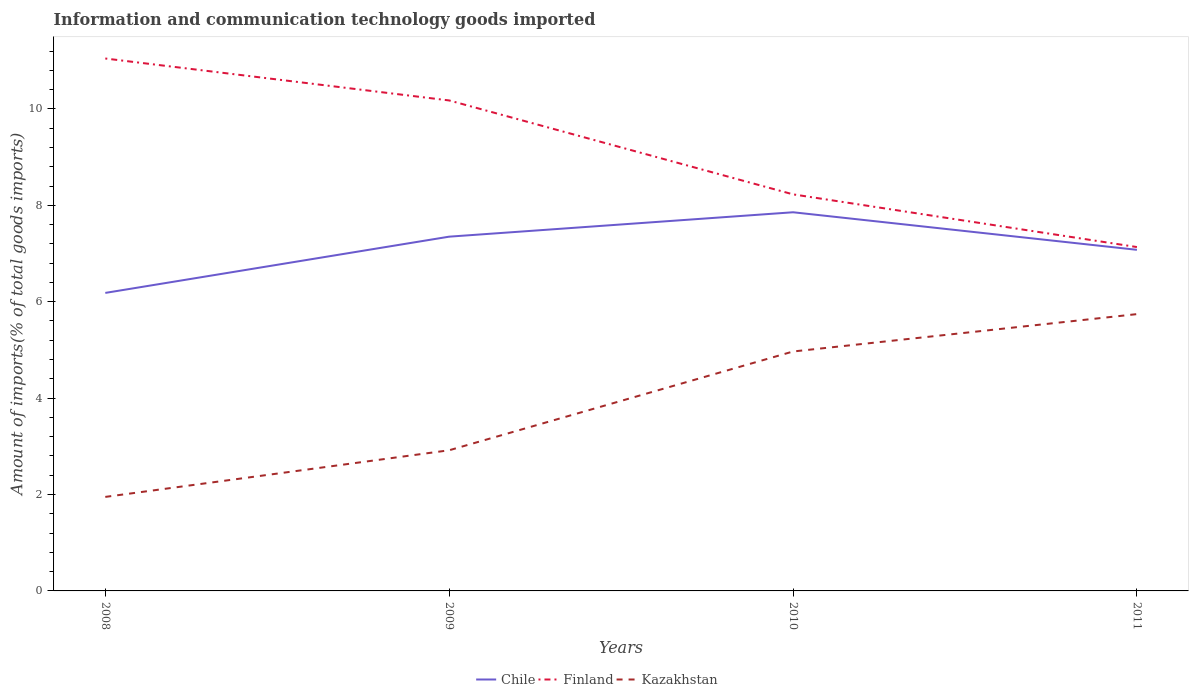How many different coloured lines are there?
Offer a very short reply. 3. Does the line corresponding to Kazakhstan intersect with the line corresponding to Chile?
Offer a terse response. No. Is the number of lines equal to the number of legend labels?
Provide a short and direct response. Yes. Across all years, what is the maximum amount of goods imported in Finland?
Make the answer very short. 7.13. In which year was the amount of goods imported in Chile maximum?
Provide a short and direct response. 2008. What is the total amount of goods imported in Kazakhstan in the graph?
Your answer should be compact. -2.05. What is the difference between the highest and the second highest amount of goods imported in Chile?
Your answer should be compact. 1.67. Is the amount of goods imported in Finland strictly greater than the amount of goods imported in Chile over the years?
Offer a very short reply. No. How many lines are there?
Offer a terse response. 3. What is the difference between two consecutive major ticks on the Y-axis?
Make the answer very short. 2. Does the graph contain any zero values?
Provide a succinct answer. No. What is the title of the graph?
Provide a short and direct response. Information and communication technology goods imported. What is the label or title of the X-axis?
Give a very brief answer. Years. What is the label or title of the Y-axis?
Offer a very short reply. Amount of imports(% of total goods imports). What is the Amount of imports(% of total goods imports) of Chile in 2008?
Ensure brevity in your answer.  6.18. What is the Amount of imports(% of total goods imports) of Finland in 2008?
Provide a short and direct response. 11.05. What is the Amount of imports(% of total goods imports) of Kazakhstan in 2008?
Your response must be concise. 1.95. What is the Amount of imports(% of total goods imports) of Chile in 2009?
Offer a very short reply. 7.35. What is the Amount of imports(% of total goods imports) in Finland in 2009?
Keep it short and to the point. 10.18. What is the Amount of imports(% of total goods imports) of Kazakhstan in 2009?
Your response must be concise. 2.92. What is the Amount of imports(% of total goods imports) in Chile in 2010?
Provide a short and direct response. 7.86. What is the Amount of imports(% of total goods imports) in Finland in 2010?
Your answer should be very brief. 8.23. What is the Amount of imports(% of total goods imports) of Kazakhstan in 2010?
Offer a very short reply. 4.97. What is the Amount of imports(% of total goods imports) in Chile in 2011?
Your answer should be compact. 7.08. What is the Amount of imports(% of total goods imports) in Finland in 2011?
Give a very brief answer. 7.13. What is the Amount of imports(% of total goods imports) in Kazakhstan in 2011?
Provide a short and direct response. 5.74. Across all years, what is the maximum Amount of imports(% of total goods imports) in Chile?
Ensure brevity in your answer.  7.86. Across all years, what is the maximum Amount of imports(% of total goods imports) in Finland?
Your answer should be very brief. 11.05. Across all years, what is the maximum Amount of imports(% of total goods imports) in Kazakhstan?
Your answer should be compact. 5.74. Across all years, what is the minimum Amount of imports(% of total goods imports) of Chile?
Ensure brevity in your answer.  6.18. Across all years, what is the minimum Amount of imports(% of total goods imports) in Finland?
Provide a succinct answer. 7.13. Across all years, what is the minimum Amount of imports(% of total goods imports) in Kazakhstan?
Provide a succinct answer. 1.95. What is the total Amount of imports(% of total goods imports) in Chile in the graph?
Your answer should be compact. 28.46. What is the total Amount of imports(% of total goods imports) of Finland in the graph?
Offer a terse response. 36.58. What is the total Amount of imports(% of total goods imports) in Kazakhstan in the graph?
Offer a terse response. 15.58. What is the difference between the Amount of imports(% of total goods imports) in Chile in 2008 and that in 2009?
Your answer should be compact. -1.17. What is the difference between the Amount of imports(% of total goods imports) in Finland in 2008 and that in 2009?
Offer a terse response. 0.87. What is the difference between the Amount of imports(% of total goods imports) in Kazakhstan in 2008 and that in 2009?
Your response must be concise. -0.97. What is the difference between the Amount of imports(% of total goods imports) in Chile in 2008 and that in 2010?
Give a very brief answer. -1.67. What is the difference between the Amount of imports(% of total goods imports) of Finland in 2008 and that in 2010?
Your answer should be very brief. 2.82. What is the difference between the Amount of imports(% of total goods imports) of Kazakhstan in 2008 and that in 2010?
Ensure brevity in your answer.  -3.02. What is the difference between the Amount of imports(% of total goods imports) in Chile in 2008 and that in 2011?
Keep it short and to the point. -0.89. What is the difference between the Amount of imports(% of total goods imports) of Finland in 2008 and that in 2011?
Your answer should be very brief. 3.91. What is the difference between the Amount of imports(% of total goods imports) of Kazakhstan in 2008 and that in 2011?
Ensure brevity in your answer.  -3.79. What is the difference between the Amount of imports(% of total goods imports) in Chile in 2009 and that in 2010?
Ensure brevity in your answer.  -0.51. What is the difference between the Amount of imports(% of total goods imports) in Finland in 2009 and that in 2010?
Provide a succinct answer. 1.95. What is the difference between the Amount of imports(% of total goods imports) of Kazakhstan in 2009 and that in 2010?
Make the answer very short. -2.05. What is the difference between the Amount of imports(% of total goods imports) of Chile in 2009 and that in 2011?
Ensure brevity in your answer.  0.27. What is the difference between the Amount of imports(% of total goods imports) of Finland in 2009 and that in 2011?
Provide a short and direct response. 3.04. What is the difference between the Amount of imports(% of total goods imports) in Kazakhstan in 2009 and that in 2011?
Your response must be concise. -2.82. What is the difference between the Amount of imports(% of total goods imports) of Chile in 2010 and that in 2011?
Keep it short and to the point. 0.78. What is the difference between the Amount of imports(% of total goods imports) of Finland in 2010 and that in 2011?
Offer a very short reply. 1.09. What is the difference between the Amount of imports(% of total goods imports) in Kazakhstan in 2010 and that in 2011?
Provide a succinct answer. -0.78. What is the difference between the Amount of imports(% of total goods imports) of Chile in 2008 and the Amount of imports(% of total goods imports) of Finland in 2009?
Your response must be concise. -3.99. What is the difference between the Amount of imports(% of total goods imports) of Chile in 2008 and the Amount of imports(% of total goods imports) of Kazakhstan in 2009?
Give a very brief answer. 3.26. What is the difference between the Amount of imports(% of total goods imports) in Finland in 2008 and the Amount of imports(% of total goods imports) in Kazakhstan in 2009?
Offer a terse response. 8.13. What is the difference between the Amount of imports(% of total goods imports) of Chile in 2008 and the Amount of imports(% of total goods imports) of Finland in 2010?
Give a very brief answer. -2.04. What is the difference between the Amount of imports(% of total goods imports) of Chile in 2008 and the Amount of imports(% of total goods imports) of Kazakhstan in 2010?
Your answer should be very brief. 1.22. What is the difference between the Amount of imports(% of total goods imports) in Finland in 2008 and the Amount of imports(% of total goods imports) in Kazakhstan in 2010?
Your answer should be very brief. 6.08. What is the difference between the Amount of imports(% of total goods imports) in Chile in 2008 and the Amount of imports(% of total goods imports) in Finland in 2011?
Your response must be concise. -0.95. What is the difference between the Amount of imports(% of total goods imports) of Chile in 2008 and the Amount of imports(% of total goods imports) of Kazakhstan in 2011?
Offer a terse response. 0.44. What is the difference between the Amount of imports(% of total goods imports) of Finland in 2008 and the Amount of imports(% of total goods imports) of Kazakhstan in 2011?
Provide a succinct answer. 5.3. What is the difference between the Amount of imports(% of total goods imports) in Chile in 2009 and the Amount of imports(% of total goods imports) in Finland in 2010?
Provide a succinct answer. -0.88. What is the difference between the Amount of imports(% of total goods imports) of Chile in 2009 and the Amount of imports(% of total goods imports) of Kazakhstan in 2010?
Keep it short and to the point. 2.38. What is the difference between the Amount of imports(% of total goods imports) in Finland in 2009 and the Amount of imports(% of total goods imports) in Kazakhstan in 2010?
Your response must be concise. 5.21. What is the difference between the Amount of imports(% of total goods imports) of Chile in 2009 and the Amount of imports(% of total goods imports) of Finland in 2011?
Give a very brief answer. 0.22. What is the difference between the Amount of imports(% of total goods imports) in Chile in 2009 and the Amount of imports(% of total goods imports) in Kazakhstan in 2011?
Offer a very short reply. 1.61. What is the difference between the Amount of imports(% of total goods imports) of Finland in 2009 and the Amount of imports(% of total goods imports) of Kazakhstan in 2011?
Make the answer very short. 4.43. What is the difference between the Amount of imports(% of total goods imports) of Chile in 2010 and the Amount of imports(% of total goods imports) of Finland in 2011?
Offer a terse response. 0.72. What is the difference between the Amount of imports(% of total goods imports) in Chile in 2010 and the Amount of imports(% of total goods imports) in Kazakhstan in 2011?
Make the answer very short. 2.11. What is the difference between the Amount of imports(% of total goods imports) in Finland in 2010 and the Amount of imports(% of total goods imports) in Kazakhstan in 2011?
Make the answer very short. 2.48. What is the average Amount of imports(% of total goods imports) in Chile per year?
Make the answer very short. 7.12. What is the average Amount of imports(% of total goods imports) of Finland per year?
Your answer should be compact. 9.15. What is the average Amount of imports(% of total goods imports) in Kazakhstan per year?
Provide a succinct answer. 3.89. In the year 2008, what is the difference between the Amount of imports(% of total goods imports) in Chile and Amount of imports(% of total goods imports) in Finland?
Give a very brief answer. -4.86. In the year 2008, what is the difference between the Amount of imports(% of total goods imports) in Chile and Amount of imports(% of total goods imports) in Kazakhstan?
Keep it short and to the point. 4.23. In the year 2008, what is the difference between the Amount of imports(% of total goods imports) in Finland and Amount of imports(% of total goods imports) in Kazakhstan?
Your response must be concise. 9.1. In the year 2009, what is the difference between the Amount of imports(% of total goods imports) in Chile and Amount of imports(% of total goods imports) in Finland?
Provide a succinct answer. -2.83. In the year 2009, what is the difference between the Amount of imports(% of total goods imports) of Chile and Amount of imports(% of total goods imports) of Kazakhstan?
Make the answer very short. 4.43. In the year 2009, what is the difference between the Amount of imports(% of total goods imports) of Finland and Amount of imports(% of total goods imports) of Kazakhstan?
Offer a very short reply. 7.26. In the year 2010, what is the difference between the Amount of imports(% of total goods imports) of Chile and Amount of imports(% of total goods imports) of Finland?
Keep it short and to the point. -0.37. In the year 2010, what is the difference between the Amount of imports(% of total goods imports) in Chile and Amount of imports(% of total goods imports) in Kazakhstan?
Offer a very short reply. 2.89. In the year 2010, what is the difference between the Amount of imports(% of total goods imports) in Finland and Amount of imports(% of total goods imports) in Kazakhstan?
Provide a succinct answer. 3.26. In the year 2011, what is the difference between the Amount of imports(% of total goods imports) of Chile and Amount of imports(% of total goods imports) of Finland?
Give a very brief answer. -0.06. In the year 2011, what is the difference between the Amount of imports(% of total goods imports) of Chile and Amount of imports(% of total goods imports) of Kazakhstan?
Your response must be concise. 1.33. In the year 2011, what is the difference between the Amount of imports(% of total goods imports) of Finland and Amount of imports(% of total goods imports) of Kazakhstan?
Provide a succinct answer. 1.39. What is the ratio of the Amount of imports(% of total goods imports) of Chile in 2008 to that in 2009?
Keep it short and to the point. 0.84. What is the ratio of the Amount of imports(% of total goods imports) in Finland in 2008 to that in 2009?
Your answer should be compact. 1.09. What is the ratio of the Amount of imports(% of total goods imports) in Kazakhstan in 2008 to that in 2009?
Offer a terse response. 0.67. What is the ratio of the Amount of imports(% of total goods imports) in Chile in 2008 to that in 2010?
Ensure brevity in your answer.  0.79. What is the ratio of the Amount of imports(% of total goods imports) in Finland in 2008 to that in 2010?
Your response must be concise. 1.34. What is the ratio of the Amount of imports(% of total goods imports) of Kazakhstan in 2008 to that in 2010?
Your answer should be very brief. 0.39. What is the ratio of the Amount of imports(% of total goods imports) in Chile in 2008 to that in 2011?
Your answer should be very brief. 0.87. What is the ratio of the Amount of imports(% of total goods imports) in Finland in 2008 to that in 2011?
Make the answer very short. 1.55. What is the ratio of the Amount of imports(% of total goods imports) in Kazakhstan in 2008 to that in 2011?
Provide a short and direct response. 0.34. What is the ratio of the Amount of imports(% of total goods imports) of Chile in 2009 to that in 2010?
Provide a short and direct response. 0.94. What is the ratio of the Amount of imports(% of total goods imports) of Finland in 2009 to that in 2010?
Provide a succinct answer. 1.24. What is the ratio of the Amount of imports(% of total goods imports) in Kazakhstan in 2009 to that in 2010?
Your answer should be compact. 0.59. What is the ratio of the Amount of imports(% of total goods imports) in Chile in 2009 to that in 2011?
Your answer should be compact. 1.04. What is the ratio of the Amount of imports(% of total goods imports) in Finland in 2009 to that in 2011?
Your answer should be compact. 1.43. What is the ratio of the Amount of imports(% of total goods imports) of Kazakhstan in 2009 to that in 2011?
Your answer should be very brief. 0.51. What is the ratio of the Amount of imports(% of total goods imports) of Chile in 2010 to that in 2011?
Provide a short and direct response. 1.11. What is the ratio of the Amount of imports(% of total goods imports) in Finland in 2010 to that in 2011?
Ensure brevity in your answer.  1.15. What is the ratio of the Amount of imports(% of total goods imports) of Kazakhstan in 2010 to that in 2011?
Provide a succinct answer. 0.86. What is the difference between the highest and the second highest Amount of imports(% of total goods imports) in Chile?
Give a very brief answer. 0.51. What is the difference between the highest and the second highest Amount of imports(% of total goods imports) in Finland?
Offer a very short reply. 0.87. What is the difference between the highest and the second highest Amount of imports(% of total goods imports) in Kazakhstan?
Give a very brief answer. 0.78. What is the difference between the highest and the lowest Amount of imports(% of total goods imports) in Chile?
Ensure brevity in your answer.  1.67. What is the difference between the highest and the lowest Amount of imports(% of total goods imports) of Finland?
Provide a short and direct response. 3.91. What is the difference between the highest and the lowest Amount of imports(% of total goods imports) of Kazakhstan?
Keep it short and to the point. 3.79. 